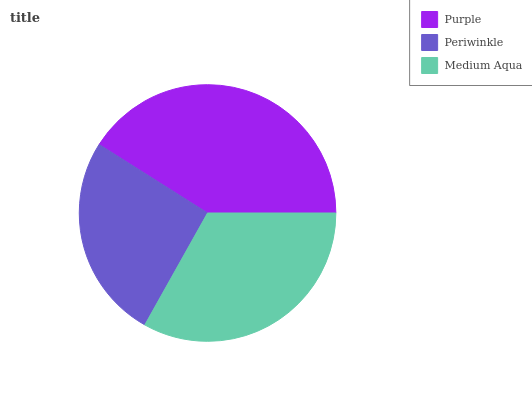Is Periwinkle the minimum?
Answer yes or no. Yes. Is Purple the maximum?
Answer yes or no. Yes. Is Medium Aqua the minimum?
Answer yes or no. No. Is Medium Aqua the maximum?
Answer yes or no. No. Is Medium Aqua greater than Periwinkle?
Answer yes or no. Yes. Is Periwinkle less than Medium Aqua?
Answer yes or no. Yes. Is Periwinkle greater than Medium Aqua?
Answer yes or no. No. Is Medium Aqua less than Periwinkle?
Answer yes or no. No. Is Medium Aqua the high median?
Answer yes or no. Yes. Is Medium Aqua the low median?
Answer yes or no. Yes. Is Purple the high median?
Answer yes or no. No. Is Purple the low median?
Answer yes or no. No. 